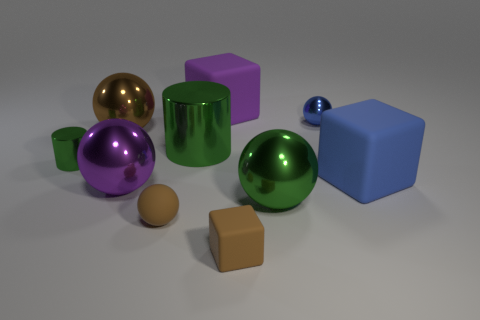Are there any tiny green shiny objects of the same shape as the blue metal object?
Make the answer very short. No. There is a big metallic thing right of the purple block; is its shape the same as the large purple thing that is in front of the brown shiny object?
Provide a succinct answer. Yes. There is a brown sphere that is the same size as the purple cube; what material is it?
Give a very brief answer. Metal. What number of other things are there of the same material as the small cube
Your answer should be very brief. 3. The rubber thing on the left side of the big purple object right of the purple ball is what shape?
Make the answer very short. Sphere. How many things are large gray things or matte cubes that are behind the small brown rubber ball?
Your answer should be compact. 2. How many other things are the same color as the small matte cube?
Your response must be concise. 2. How many green things are small cylinders or big metallic objects?
Provide a succinct answer. 3. Is there a brown sphere that is behind the small green object on the left side of the big matte thing that is in front of the small blue object?
Provide a succinct answer. Yes. Do the tiny matte cube and the tiny rubber sphere have the same color?
Your response must be concise. Yes. 